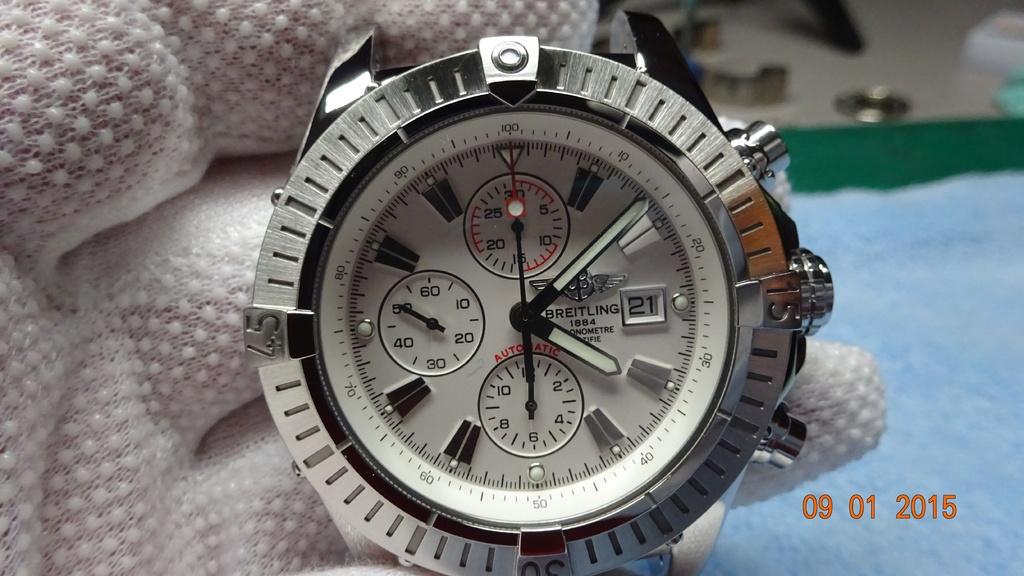What time is on the watch?
Your response must be concise. 4:09. What brand of watch is this?
Provide a short and direct response. Breitling. 